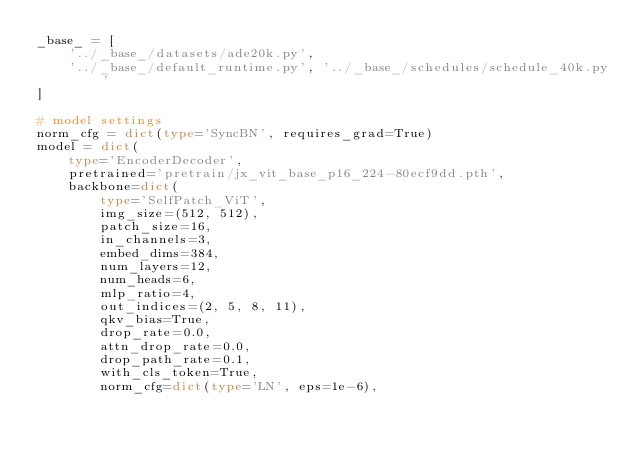<code> <loc_0><loc_0><loc_500><loc_500><_Python_>_base_ = [
    '../_base_/datasets/ade20k.py',
    '../_base_/default_runtime.py', '../_base_/schedules/schedule_40k.py'
]

# model settings
norm_cfg = dict(type='SyncBN', requires_grad=True)
model = dict(
    type='EncoderDecoder',
    pretrained='pretrain/jx_vit_base_p16_224-80ecf9dd.pth',
    backbone=dict(
        type='SelfPatch_ViT',
        img_size=(512, 512),
        patch_size=16,
        in_channels=3,
        embed_dims=384,
        num_layers=12,
        num_heads=6,
        mlp_ratio=4,
        out_indices=(2, 5, 8, 11),
        qkv_bias=True,
        drop_rate=0.0,
        attn_drop_rate=0.0,
        drop_path_rate=0.1,
        with_cls_token=True,
        norm_cfg=dict(type='LN', eps=1e-6),</code> 